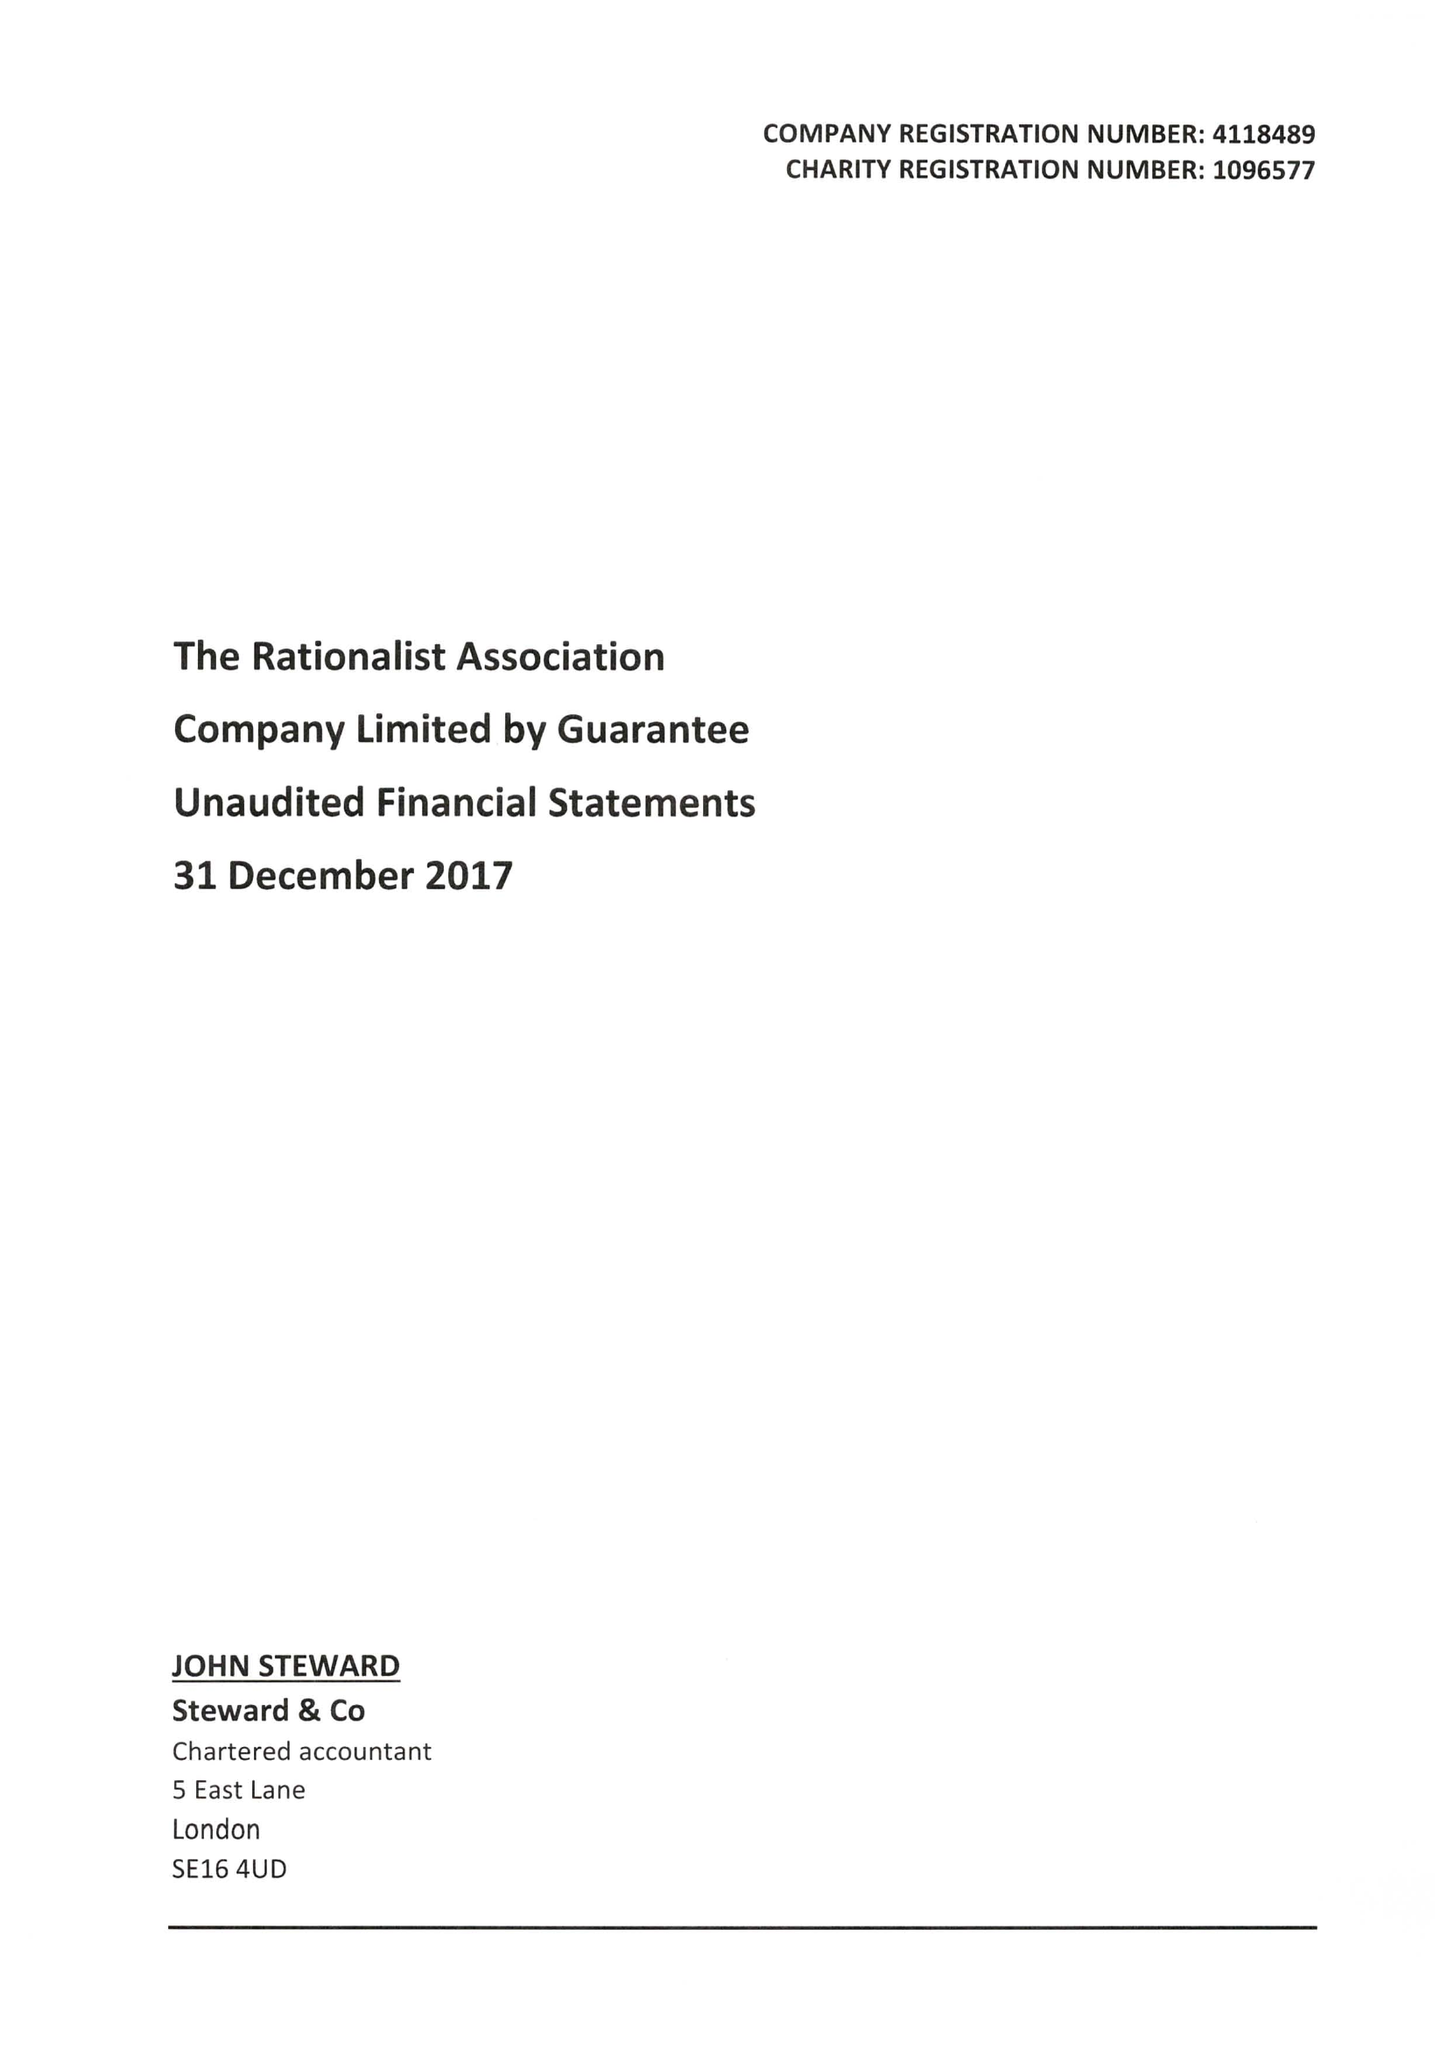What is the value for the charity_number?
Answer the question using a single word or phrase. 1096577 